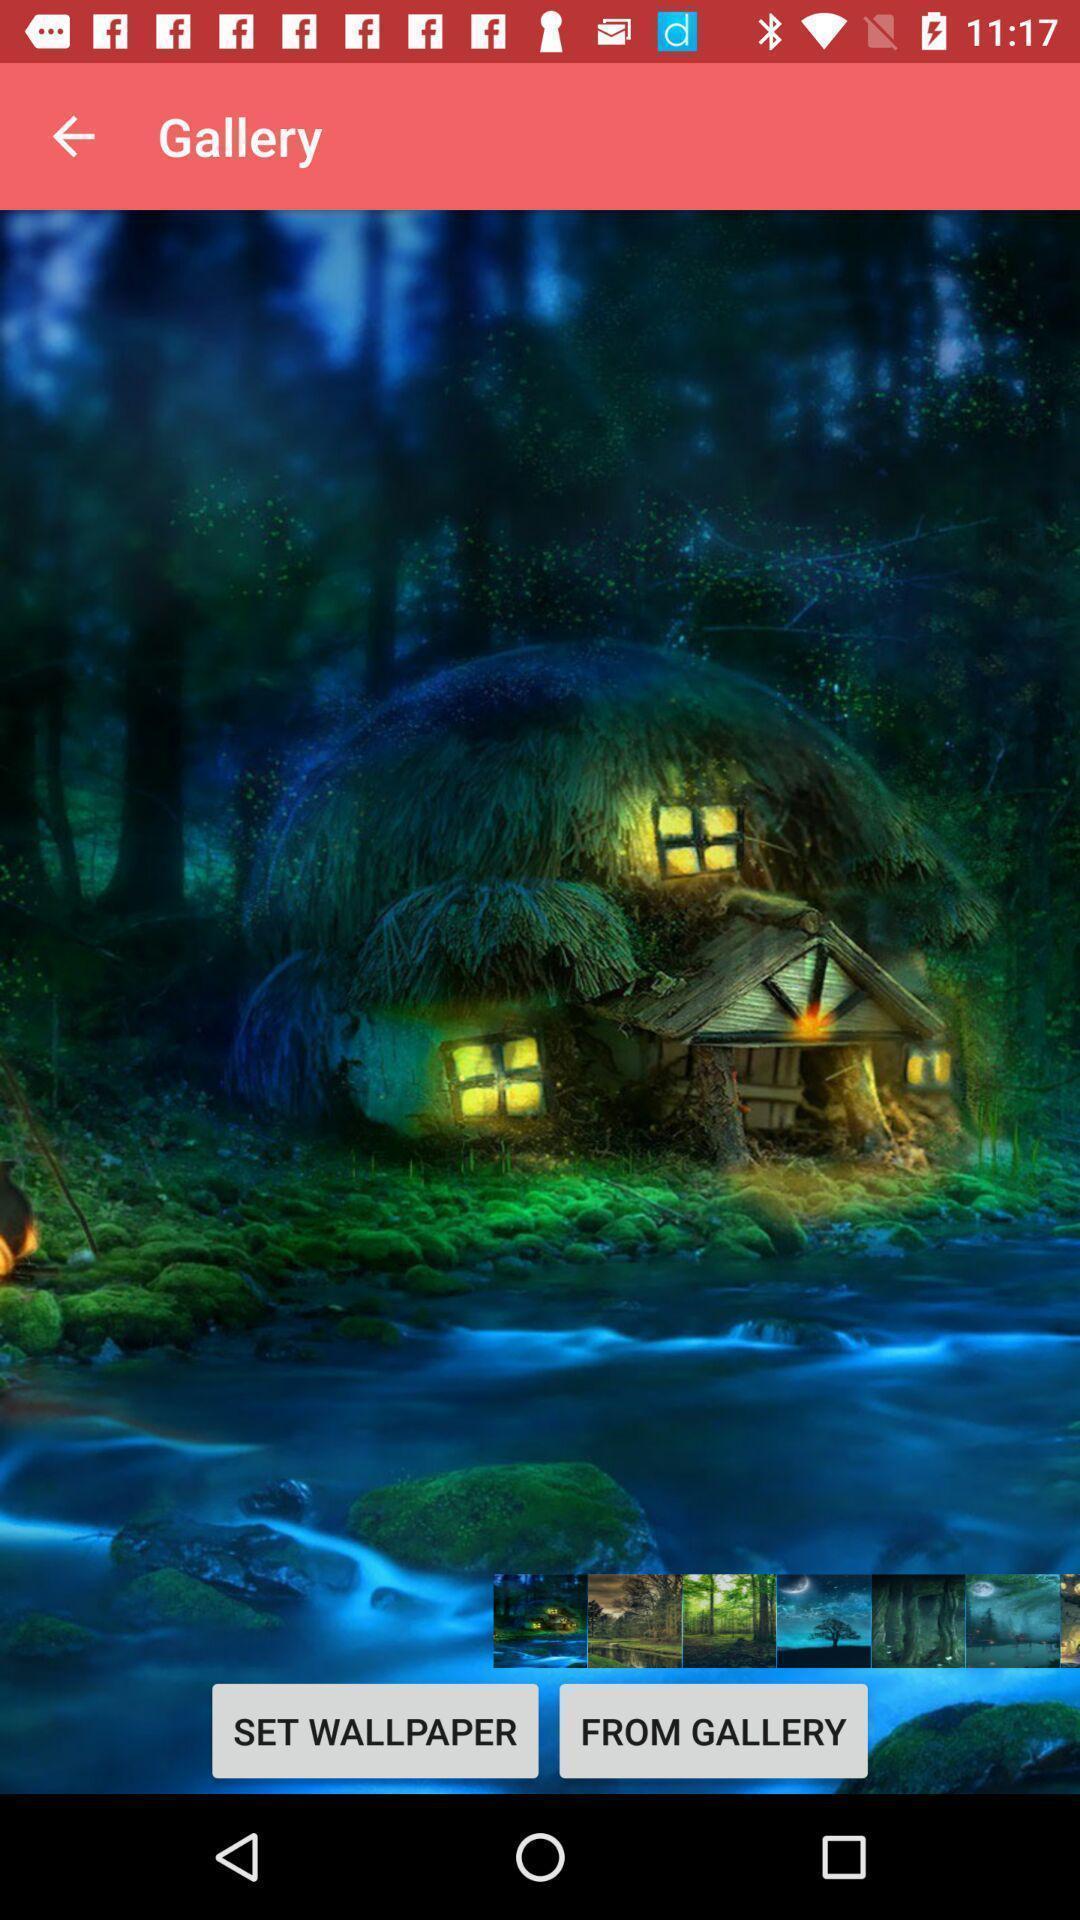Describe the content in this image. Screen showing image from gallery with options like set. 